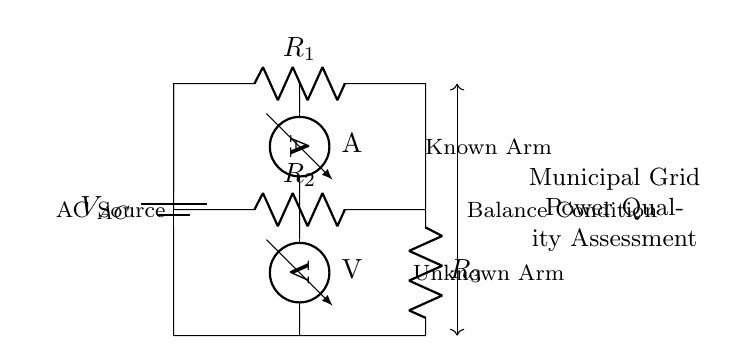What is the voltage source in this circuit? The voltage source is represented by the battery symbol and is labeled as V_AC. This indicates it is an alternating current (AC) source.
Answer: V_AC What are the values of the resistors in the known arm? The known arm consists of resistors R1 and R2. The diagram only gives the labels without explicit values, so the answer is based on the component labels.
Answer: R1 and R2 What instrument is used to measure current in this circuit? The ammeter symbol in the circuit diagram indicates the instrument used to measure current, which is denoted as A. Therefore, the answer refers to the component name near the symbol.
Answer: Ammeter How many resistors are present in total within the circuit? There are three resistors labeled R1, R2, and R3. Counting each label indicates the total number of resistive elements in the circuit.
Answer: Three What is the balance condition's purpose in this bridge circuit? The balance condition is a principle that ensures equality in the potential difference across the unknown arm and the known arm of the bridge, allowing for accurate measurement. This balancing is crucial in determining characteristics of the material.
Answer: Measurement accuracy What does the voltmeter measure in this circuit? The voltmeter is represented by the V symbol and measures the potential difference across two points in the circuit, specifically across the unknown arm defined by the connections. This measurement aids in the assessment of voltage.
Answer: Voltage difference What type of circuit is this an example of? The circuit is identified as an AC bridge circuit, which is specifically designed to assess power quality in electrical grids. Its distinctive features are characteristic of bridge circuit configurations used for comparisons.
Answer: AC bridge circuit 